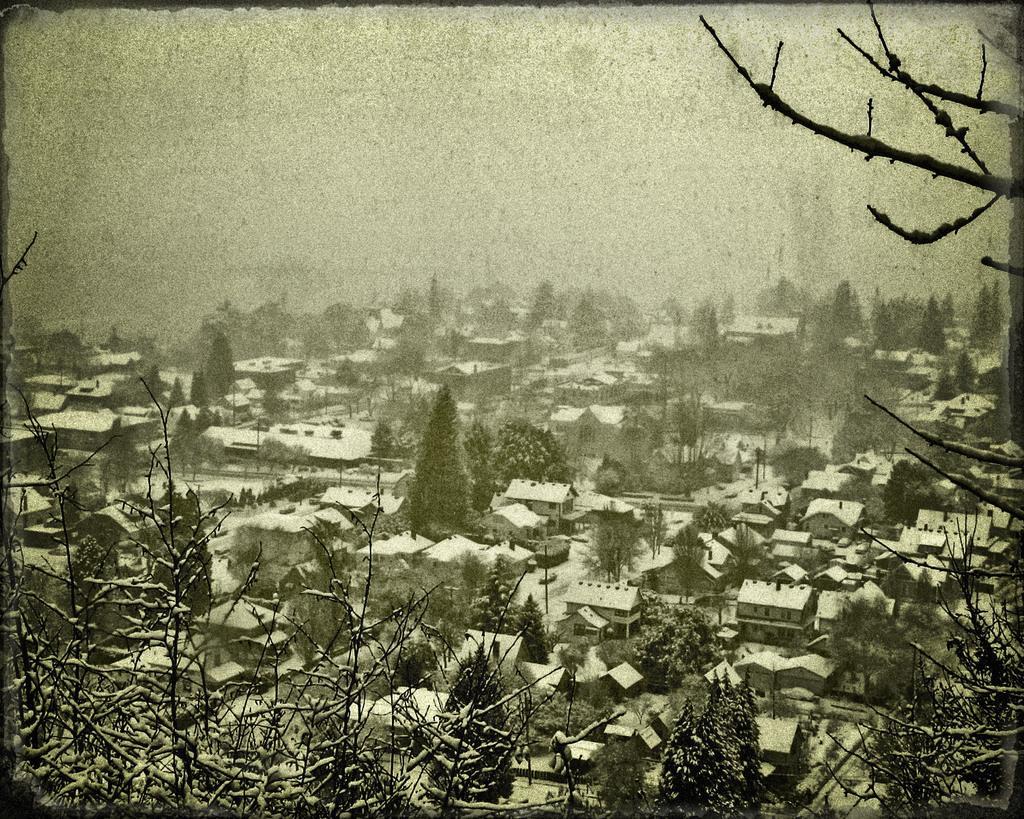Describe this image in one or two sentences. In the image we can see some trees and buildings. Top of the image there is sky. 